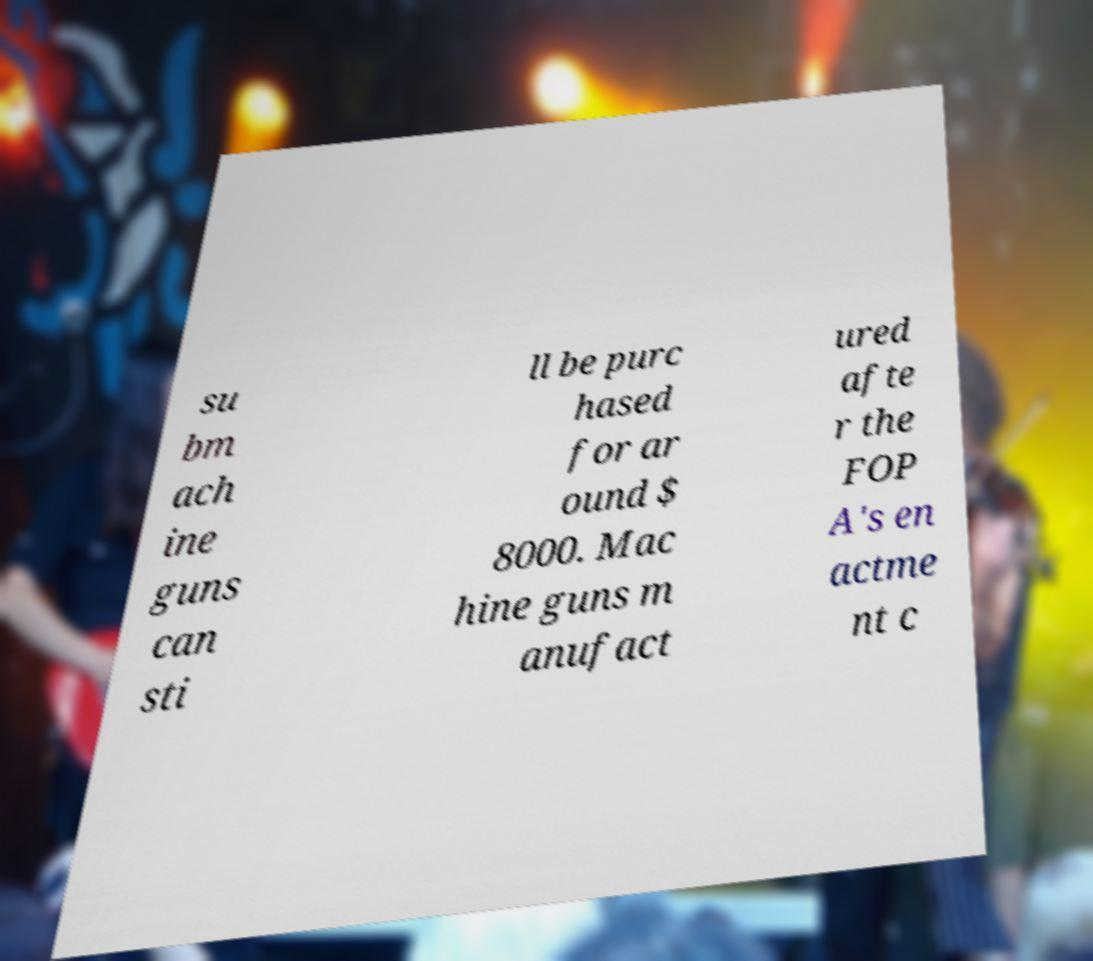What messages or text are displayed in this image? I need them in a readable, typed format. su bm ach ine guns can sti ll be purc hased for ar ound $ 8000. Mac hine guns m anufact ured afte r the FOP A's en actme nt c 